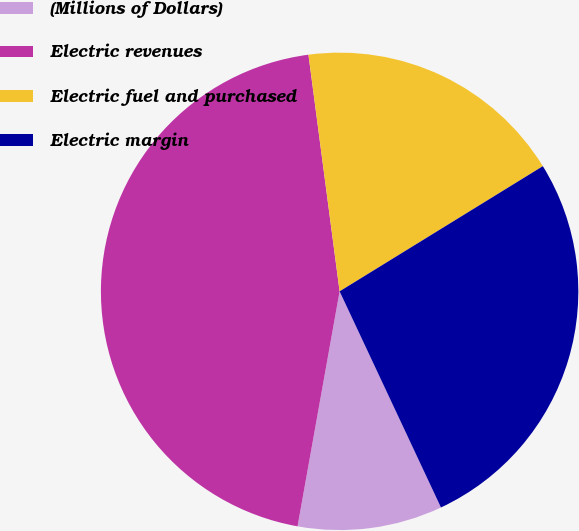Convert chart to OTSL. <chart><loc_0><loc_0><loc_500><loc_500><pie_chart><fcel>(Millions of Dollars)<fcel>Electric revenues<fcel>Electric fuel and purchased<fcel>Electric margin<nl><fcel>9.8%<fcel>45.1%<fcel>18.3%<fcel>26.81%<nl></chart> 